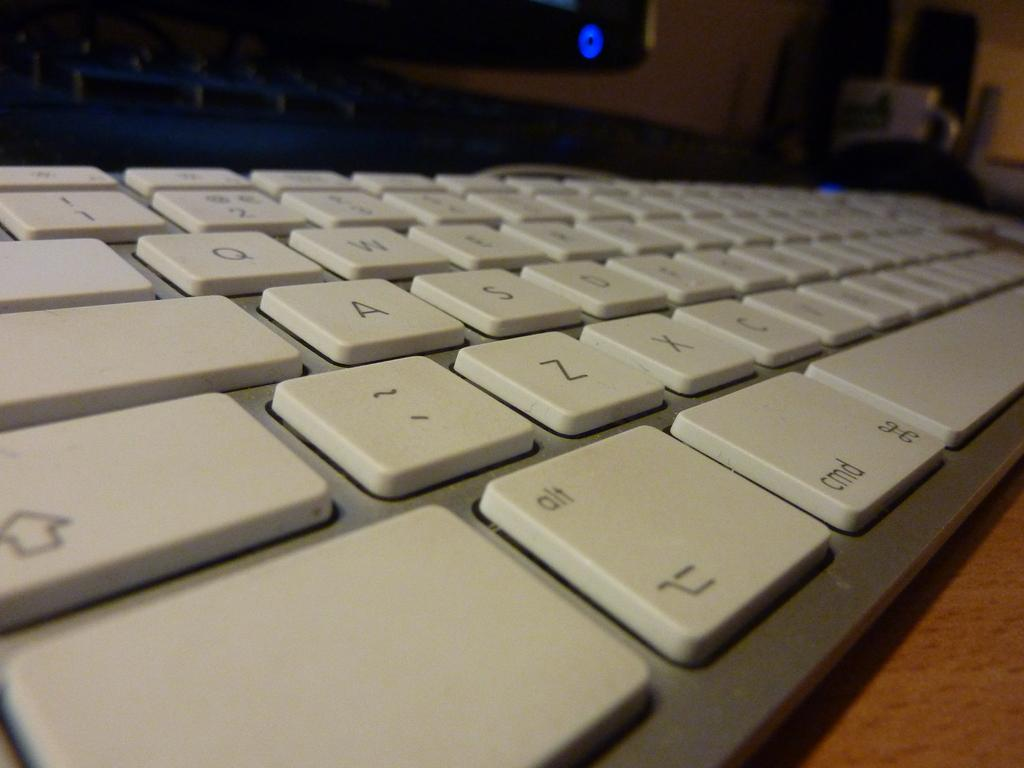<image>
Share a concise interpretation of the image provided. A QWERTY keyboard with an Apple command key 